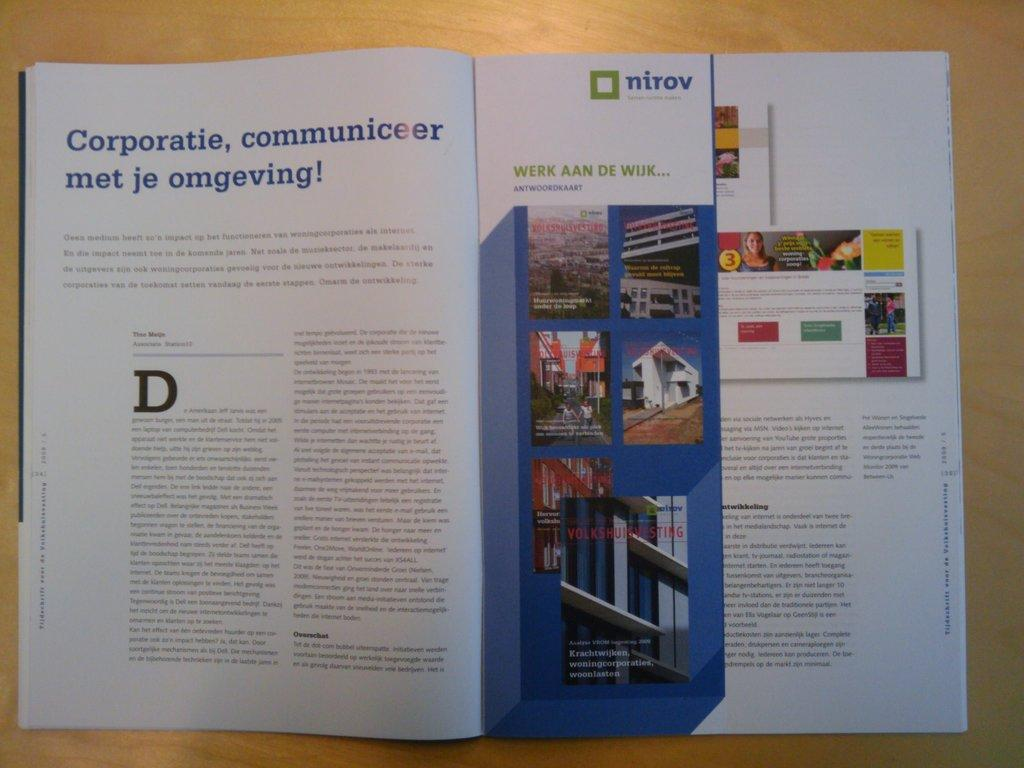<image>
Provide a brief description of the given image. A magazine is opened to a page that has "nirov" with a green box. 